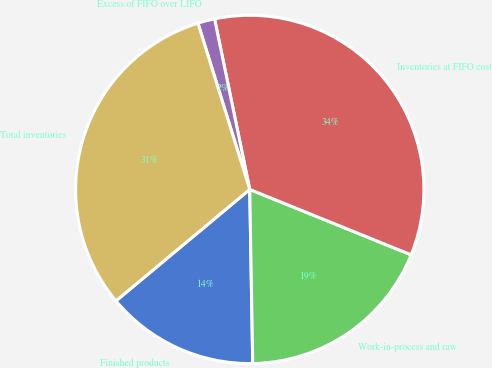Convert chart. <chart><loc_0><loc_0><loc_500><loc_500><pie_chart><fcel>Finished products<fcel>Work-in-process and raw<fcel>Inventories at FIFO cost<fcel>Excess of FIFO over LIFO<fcel>Total inventories<nl><fcel>14.22%<fcel>18.6%<fcel>34.37%<fcel>1.57%<fcel>31.25%<nl></chart> 